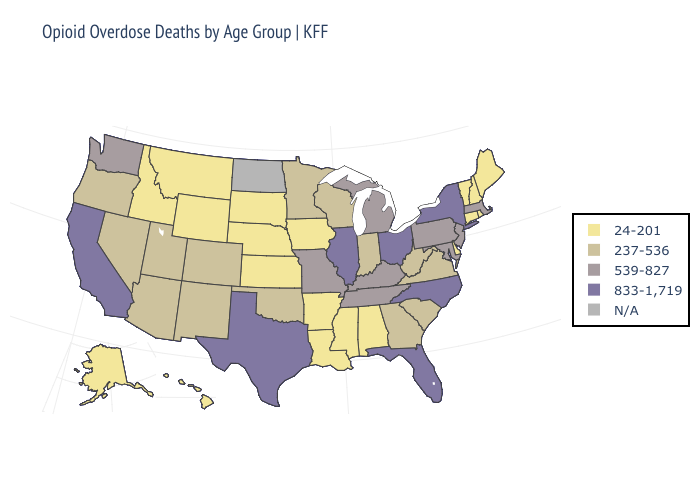Name the states that have a value in the range 24-201?
Give a very brief answer. Alabama, Alaska, Arkansas, Connecticut, Delaware, Hawaii, Idaho, Iowa, Kansas, Louisiana, Maine, Mississippi, Montana, Nebraska, New Hampshire, Rhode Island, South Dakota, Vermont, Wyoming. Name the states that have a value in the range 833-1,719?
Concise answer only. California, Florida, Illinois, New York, North Carolina, Ohio, Texas. Name the states that have a value in the range N/A?
Be succinct. North Dakota. What is the lowest value in the Northeast?
Short answer required. 24-201. Does the map have missing data?
Answer briefly. Yes. Which states have the lowest value in the USA?
Quick response, please. Alabama, Alaska, Arkansas, Connecticut, Delaware, Hawaii, Idaho, Iowa, Kansas, Louisiana, Maine, Mississippi, Montana, Nebraska, New Hampshire, Rhode Island, South Dakota, Vermont, Wyoming. Name the states that have a value in the range 24-201?
Answer briefly. Alabama, Alaska, Arkansas, Connecticut, Delaware, Hawaii, Idaho, Iowa, Kansas, Louisiana, Maine, Mississippi, Montana, Nebraska, New Hampshire, Rhode Island, South Dakota, Vermont, Wyoming. What is the highest value in the MidWest ?
Be succinct. 833-1,719. What is the lowest value in the West?
Give a very brief answer. 24-201. What is the highest value in the USA?
Quick response, please. 833-1,719. Name the states that have a value in the range 237-536?
Short answer required. Arizona, Colorado, Georgia, Indiana, Minnesota, Nevada, New Mexico, Oklahoma, Oregon, South Carolina, Utah, Virginia, West Virginia, Wisconsin. Does Indiana have the highest value in the USA?
Be succinct. No. Name the states that have a value in the range 237-536?
Short answer required. Arizona, Colorado, Georgia, Indiana, Minnesota, Nevada, New Mexico, Oklahoma, Oregon, South Carolina, Utah, Virginia, West Virginia, Wisconsin. What is the value of Wyoming?
Be succinct. 24-201. Does the first symbol in the legend represent the smallest category?
Write a very short answer. Yes. 